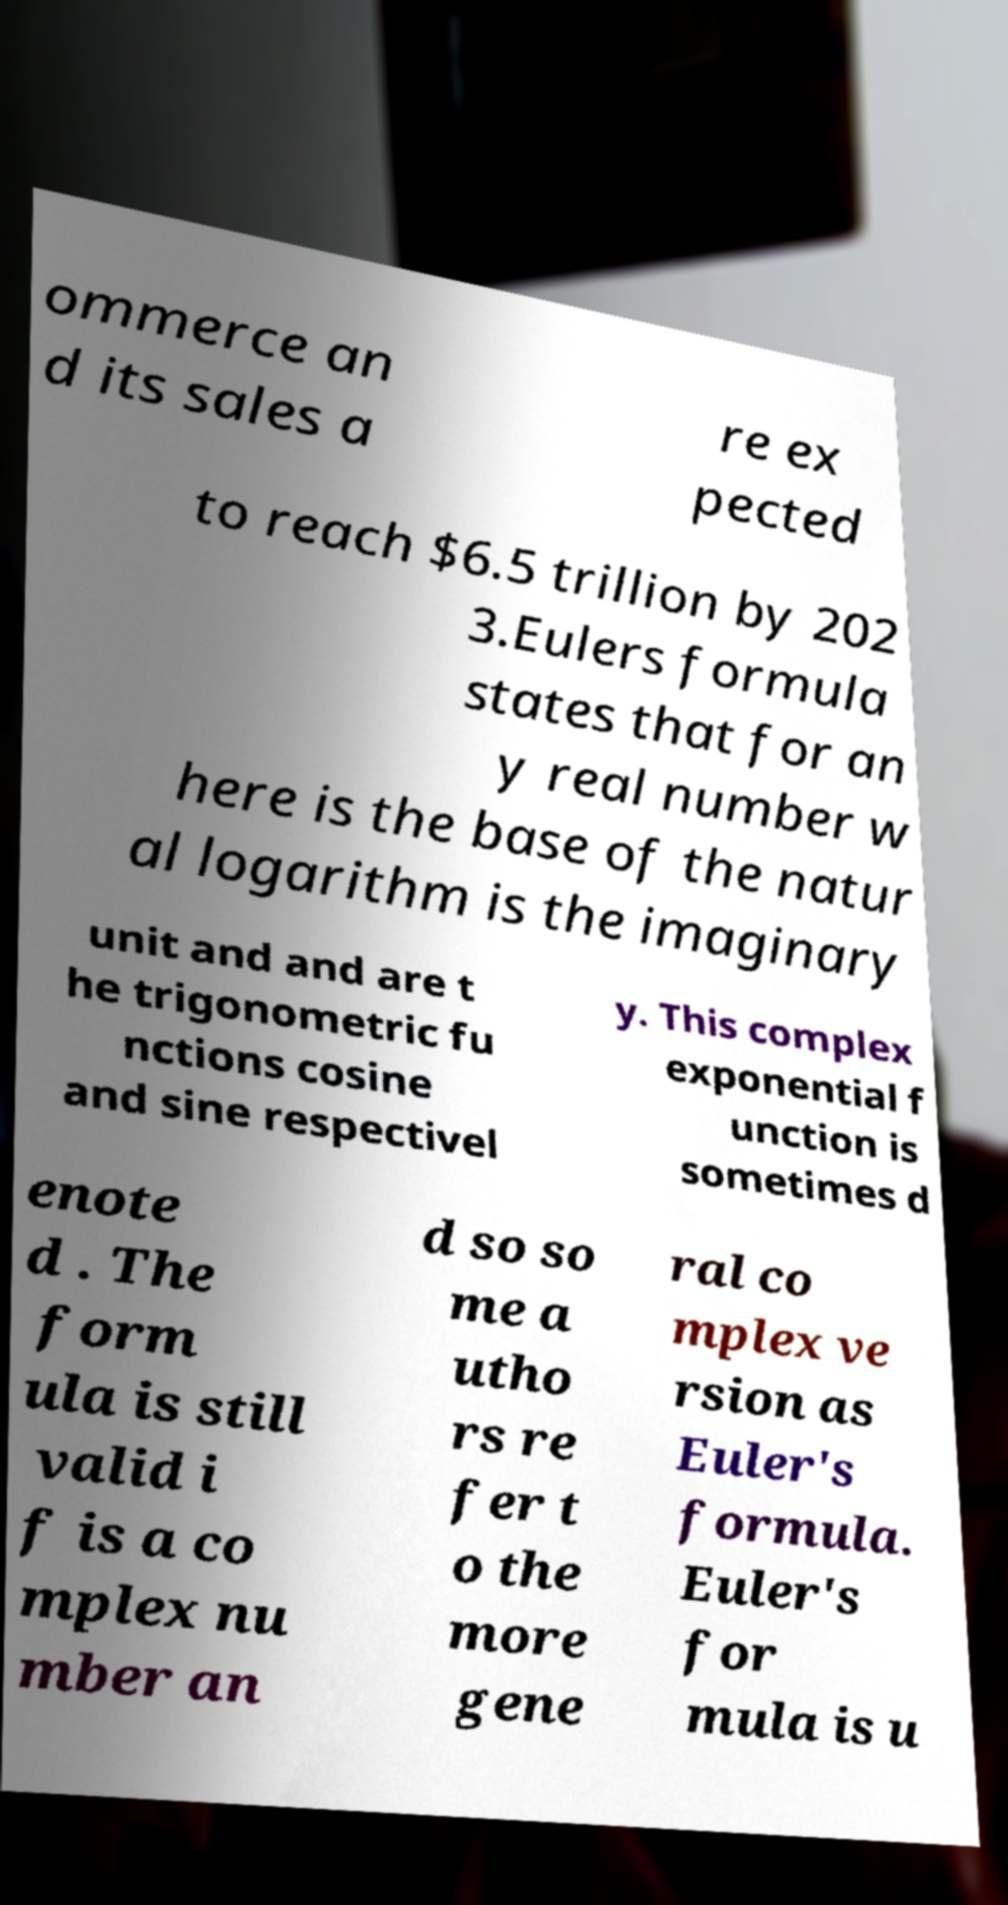Could you assist in decoding the text presented in this image and type it out clearly? ommerce an d its sales a re ex pected to reach $6.5 trillion by 202 3.Eulers formula states that for an y real number w here is the base of the natur al logarithm is the imaginary unit and and are t he trigonometric fu nctions cosine and sine respectivel y. This complex exponential f unction is sometimes d enote d . The form ula is still valid i f is a co mplex nu mber an d so so me a utho rs re fer t o the more gene ral co mplex ve rsion as Euler's formula. Euler's for mula is u 